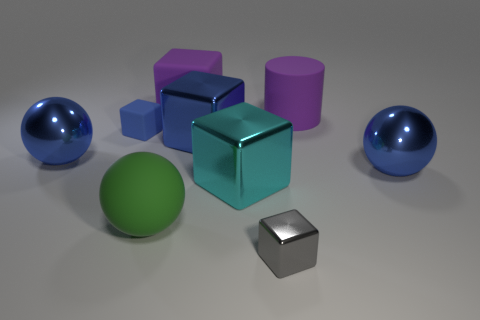How many gray cubes are there?
Make the answer very short. 1. What number of purple things are either matte cylinders or big matte things?
Make the answer very short. 2. Is the blue sphere that is on the left side of the small gray metallic thing made of the same material as the large cyan block?
Keep it short and to the point. Yes. What number of other things are there of the same material as the gray block
Provide a succinct answer. 4. What material is the cyan block?
Your response must be concise. Metal. What is the size of the blue sphere that is to the right of the tiny metallic block?
Make the answer very short. Large. There is a large shiny ball that is on the left side of the green sphere; what number of large blue metal cubes are on the right side of it?
Your answer should be compact. 1. There is a shiny object in front of the green thing; is its shape the same as the small blue object that is behind the matte sphere?
Provide a short and direct response. Yes. What number of large spheres are on the left side of the small rubber cube and to the right of the tiny shiny thing?
Give a very brief answer. 0. Is there another metallic object that has the same color as the small metal object?
Ensure brevity in your answer.  No. 